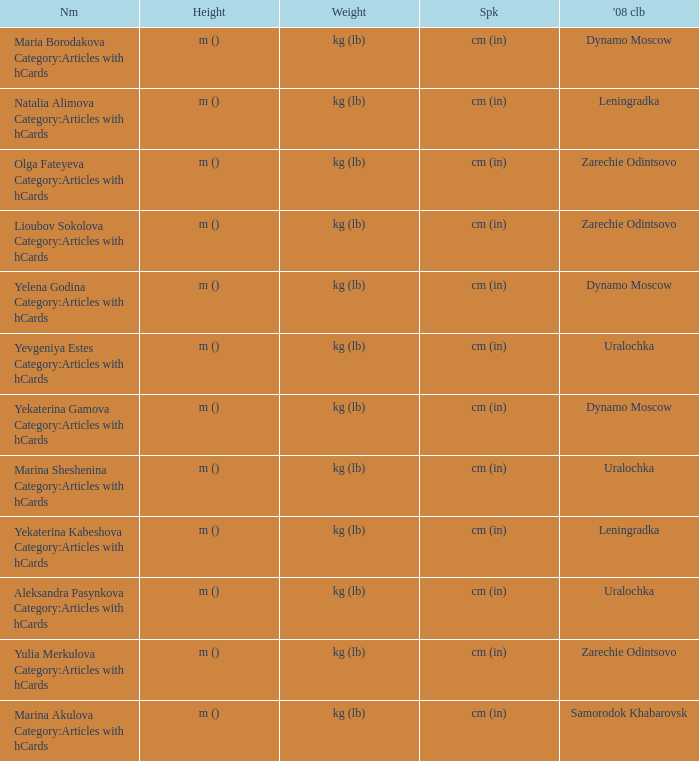Give me the full table as a dictionary. {'header': ['Nm', 'Height', 'Weight', 'Spk', "'08 clb"], 'rows': [['Maria Borodakova Category:Articles with hCards', 'm ()', 'kg (lb)', 'cm (in)', 'Dynamo Moscow'], ['Natalia Alimova Category:Articles with hCards', 'm ()', 'kg (lb)', 'cm (in)', 'Leningradka'], ['Olga Fateyeva Category:Articles with hCards', 'm ()', 'kg (lb)', 'cm (in)', 'Zarechie Odintsovo'], ['Lioubov Sokolova Category:Articles with hCards', 'm ()', 'kg (lb)', 'cm (in)', 'Zarechie Odintsovo'], ['Yelena Godina Category:Articles with hCards', 'm ()', 'kg (lb)', 'cm (in)', 'Dynamo Moscow'], ['Yevgeniya Estes Category:Articles with hCards', 'm ()', 'kg (lb)', 'cm (in)', 'Uralochka'], ['Yekaterina Gamova Category:Articles with hCards', 'm ()', 'kg (lb)', 'cm (in)', 'Dynamo Moscow'], ['Marina Sheshenina Category:Articles with hCards', 'm ()', 'kg (lb)', 'cm (in)', 'Uralochka'], ['Yekaterina Kabeshova Category:Articles with hCards', 'm ()', 'kg (lb)', 'cm (in)', 'Leningradka'], ['Aleksandra Pasynkova Category:Articles with hCards', 'm ()', 'kg (lb)', 'cm (in)', 'Uralochka'], ['Yulia Merkulova Category:Articles with hCards', 'm ()', 'kg (lb)', 'cm (in)', 'Zarechie Odintsovo'], ['Marina Akulova Category:Articles with hCards', 'm ()', 'kg (lb)', 'cm (in)', 'Samorodok Khabarovsk']]} What is the name when the 2008 club is uralochka? Yevgeniya Estes Category:Articles with hCards, Marina Sheshenina Category:Articles with hCards, Aleksandra Pasynkova Category:Articles with hCards. 